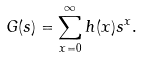<formula> <loc_0><loc_0><loc_500><loc_500>G ( s ) = \sum _ { x = 0 } ^ { \infty } h ( x ) s ^ { x } .</formula> 